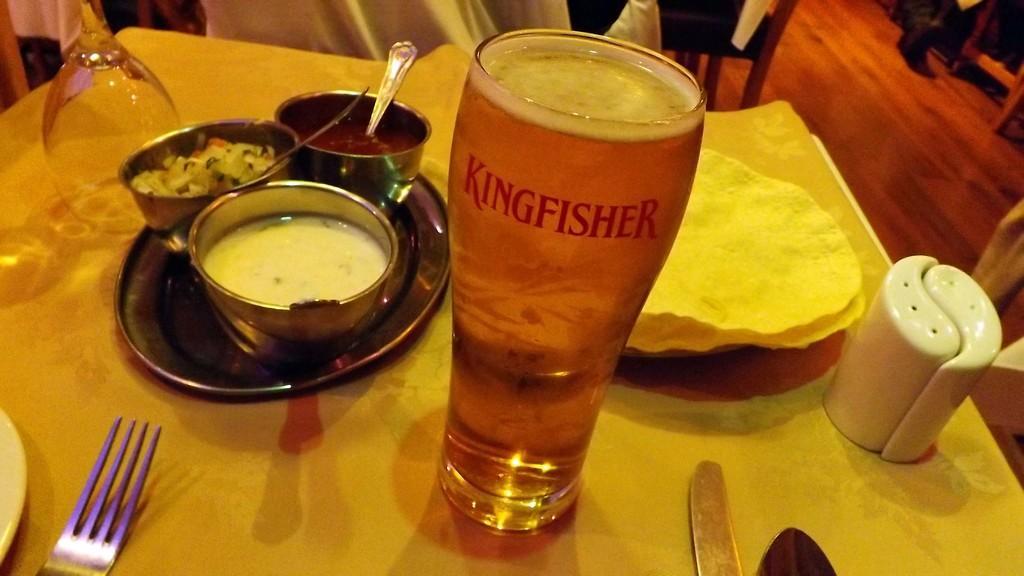Can you describe this image briefly? In this picture we can see liquid and some text on a glass. There is a fork, knife and some food items in the bowls. These balls are on a plate. We can see a glass, white object and other things on a yellow surface. We can see a few objects in the background. 